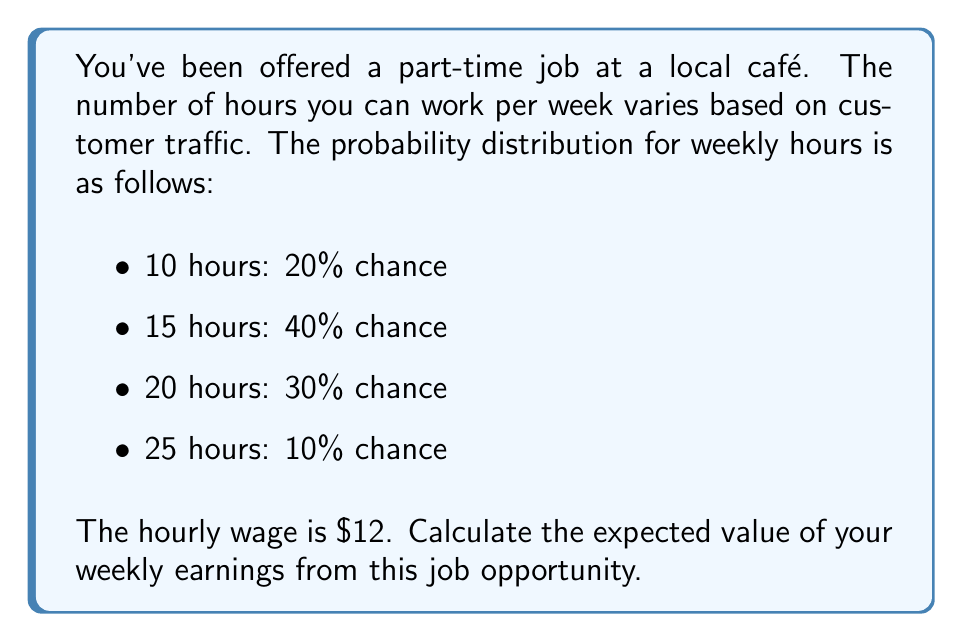What is the answer to this math problem? To calculate the expected value, we need to follow these steps:

1) First, let's calculate the earnings for each possible number of hours:
   - 10 hours: $10 \times $12 = $120
   - 15 hours: $15 \times $12 = $180
   - 20 hours: $20 \times $12 = $240
   - 25 hours: $25 \times $12 = $300

2) Now, we'll use the expected value formula:
   $$ E(X) = \sum_{i=1}^{n} x_i \cdot p(x_i) $$
   where $x_i$ is each possible outcome and $p(x_i)$ is its probability.

3) Let's substitute our values:
   $$ E(X) = 120 \cdot 0.20 + 180 \cdot 0.40 + 240 \cdot 0.30 + 300 \cdot 0.10 $$

4) Now, let's calculate:
   $$ E(X) = 24 + 72 + 72 + 30 = 198 $$

Therefore, the expected value of your weekly earnings is $198.
Answer: $198 